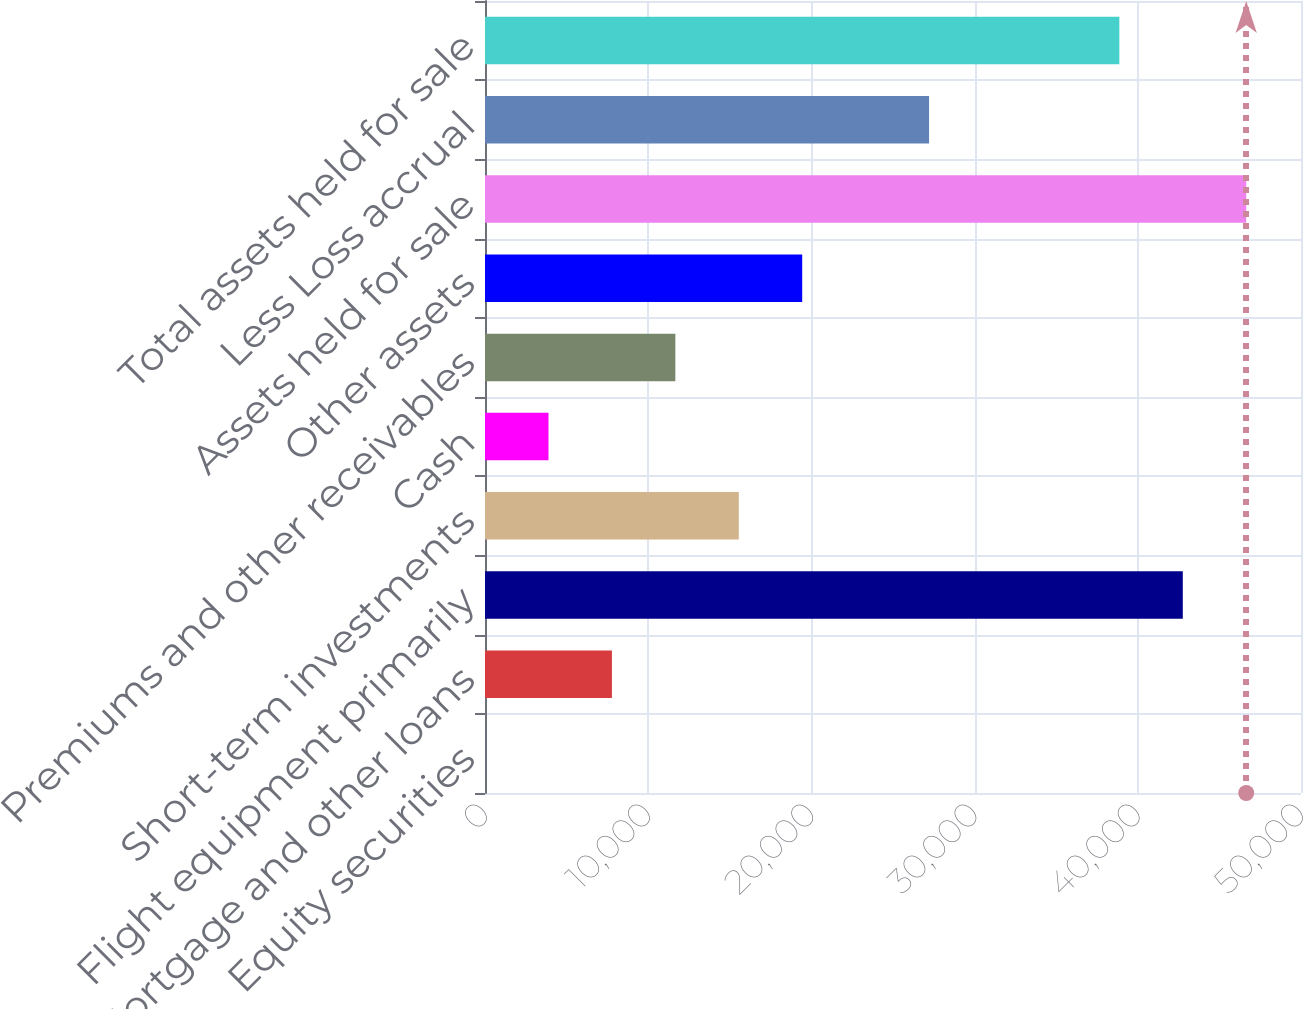Convert chart. <chart><loc_0><loc_0><loc_500><loc_500><bar_chart><fcel>Equity securities<fcel>Mortgage and other loans<fcel>Flight equipment primarily<fcel>Short-term investments<fcel>Cash<fcel>Premiums and other receivables<fcel>Other assets<fcel>Assets held for sale<fcel>Less Loss accrual<fcel>Total assets held for sale<nl><fcel>3<fcel>7776.4<fcel>42756.7<fcel>15549.8<fcel>3889.7<fcel>11663.1<fcel>19436.5<fcel>46643.4<fcel>27209.9<fcel>38870<nl></chart> 